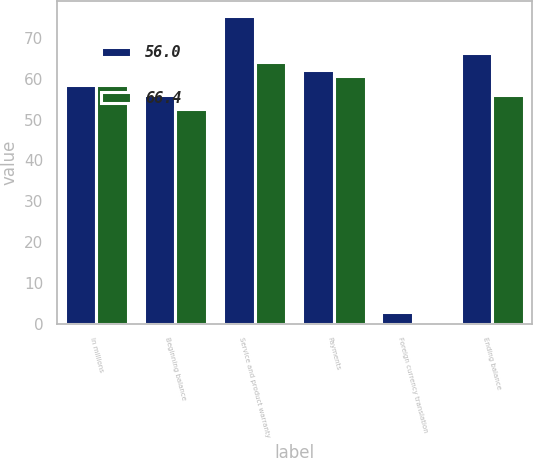Convert chart to OTSL. <chart><loc_0><loc_0><loc_500><loc_500><stacked_bar_chart><ecel><fcel>In millions<fcel>Beginning balance<fcel>Service and product warranty<fcel>Payments<fcel>Foreign currency translation<fcel>Ending balance<nl><fcel>56<fcel>58.4<fcel>56<fcel>75.3<fcel>62.1<fcel>2.8<fcel>66.4<nl><fcel>66.4<fcel>58.4<fcel>52.5<fcel>64.1<fcel>60.8<fcel>0.2<fcel>56<nl></chart> 